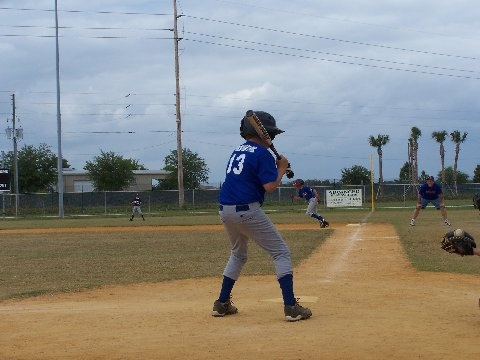Describe the objects in this image and their specific colors. I can see people in darkgray, gray, black, navy, and maroon tones, people in darkgray, black, gray, and maroon tones, people in darkgray, black, gray, and navy tones, baseball glove in darkgray, black, and gray tones, and baseball bat in darkgray, black, gray, and maroon tones in this image. 